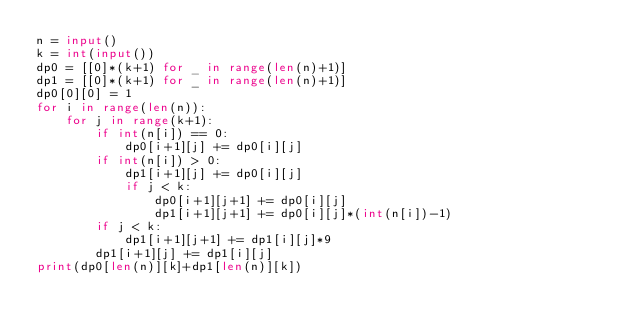Convert code to text. <code><loc_0><loc_0><loc_500><loc_500><_Python_>n = input()
k = int(input())
dp0 = [[0]*(k+1) for _ in range(len(n)+1)]
dp1 = [[0]*(k+1) for _ in range(len(n)+1)]
dp0[0][0] = 1
for i in range(len(n)):
    for j in range(k+1):
        if int(n[i]) == 0:
            dp0[i+1][j] += dp0[i][j]
        if int(n[i]) > 0:
            dp1[i+1][j] += dp0[i][j]
            if j < k:
                dp0[i+1][j+1] += dp0[i][j]
                dp1[i+1][j+1] += dp0[i][j]*(int(n[i])-1)
        if j < k:
            dp1[i+1][j+1] += dp1[i][j]*9
        dp1[i+1][j] += dp1[i][j]
print(dp0[len(n)][k]+dp1[len(n)][k])</code> 